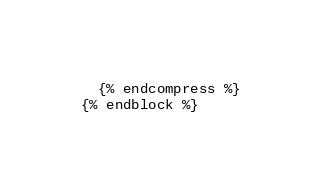Convert code to text. <code><loc_0><loc_0><loc_500><loc_500><_HTML_>
  {% endcompress %}
{% endblock %}
</code> 